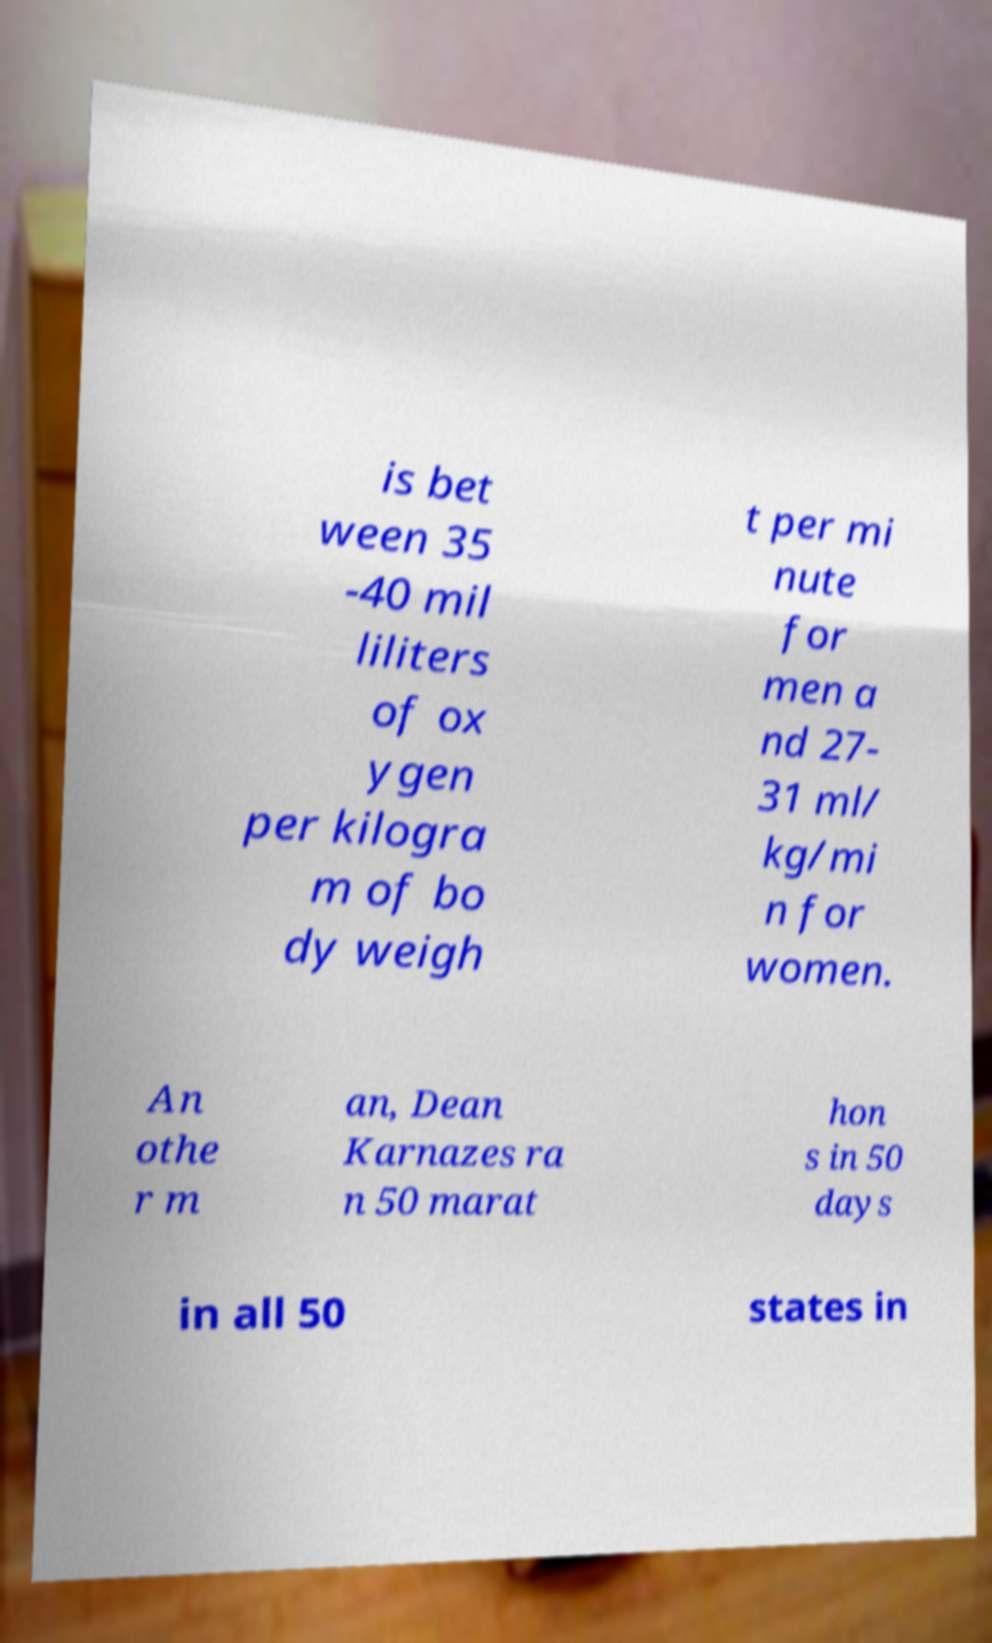Could you assist in decoding the text presented in this image and type it out clearly? is bet ween 35 -40 mil liliters of ox ygen per kilogra m of bo dy weigh t per mi nute for men a nd 27- 31 ml/ kg/mi n for women. An othe r m an, Dean Karnazes ra n 50 marat hon s in 50 days in all 50 states in 